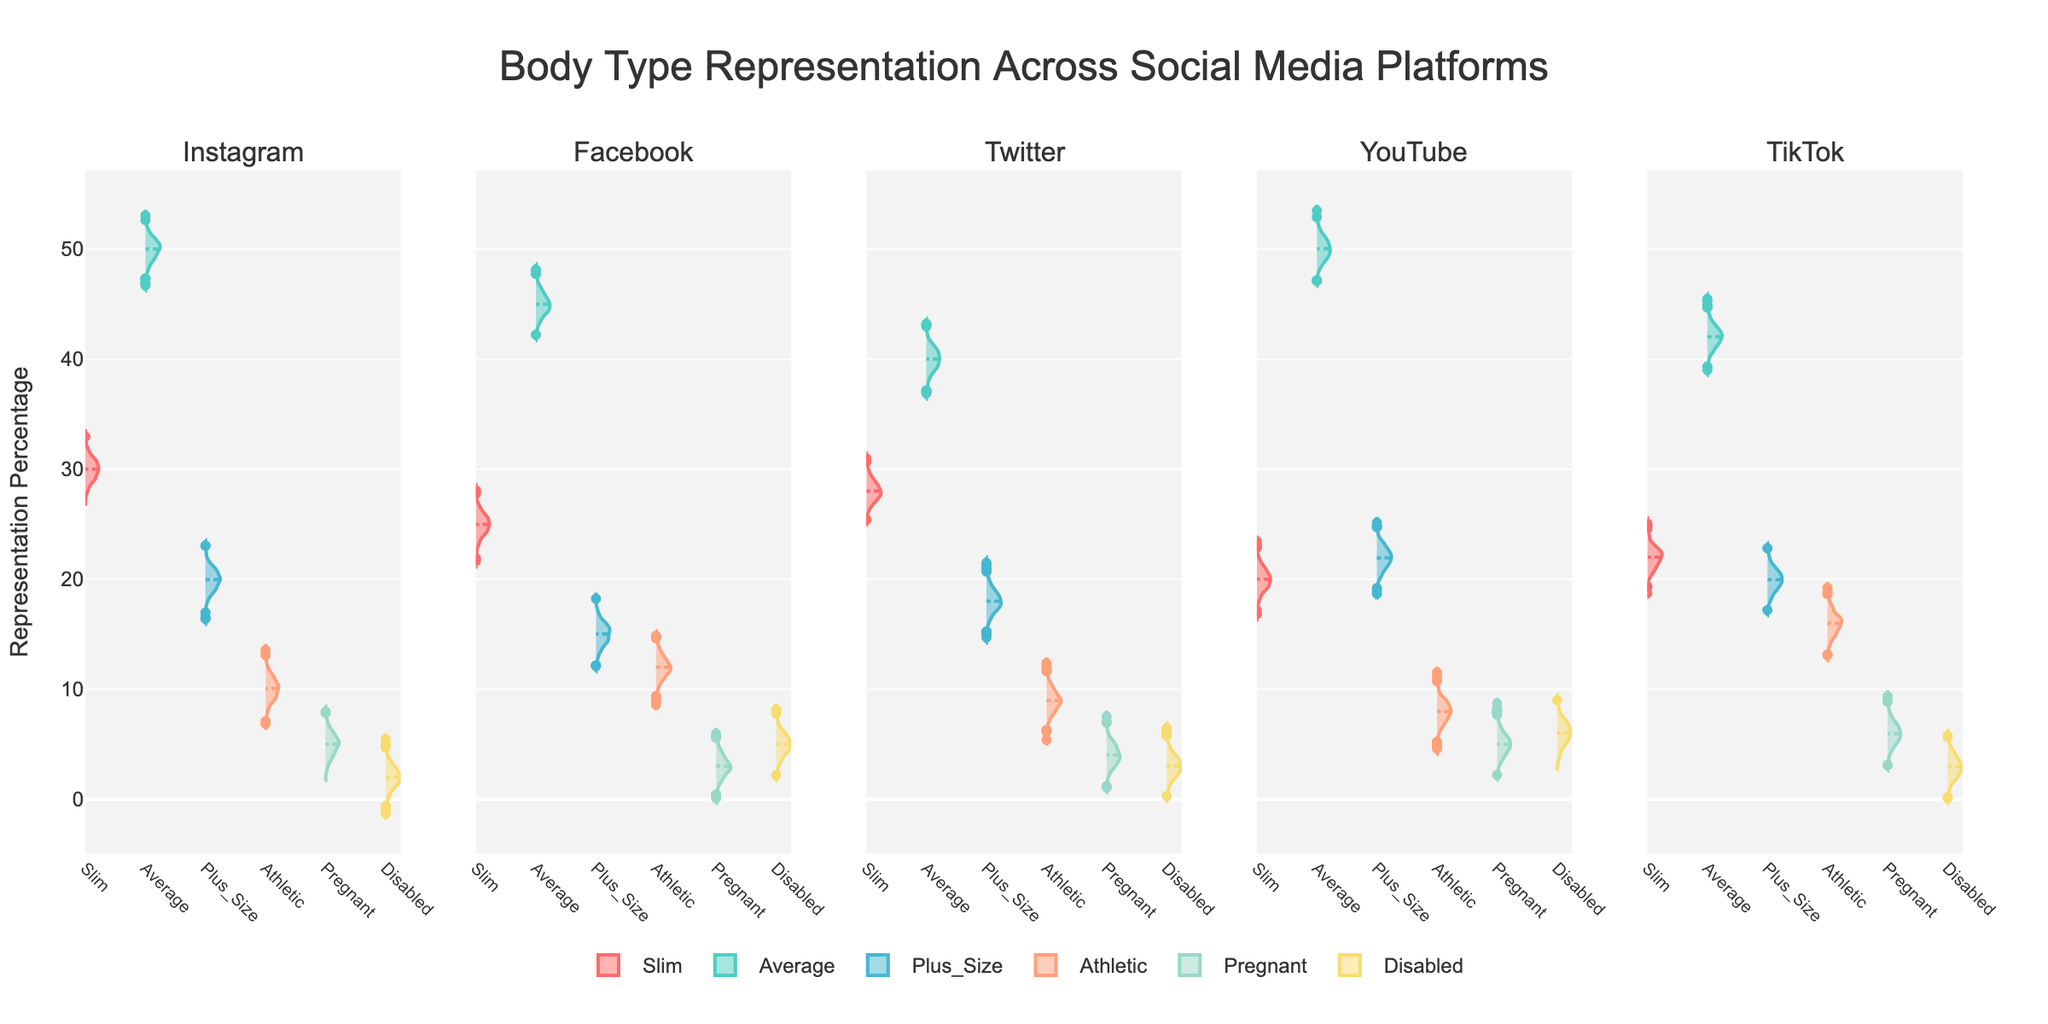What's the title of the figure? The title of the figure appears at the top center of the plot.
Answer: Body Type Representation Across Social Media Platforms How many platforms are being compared in the figure? By observing the subplot titles, we see that there are five platforms.
Answer: 5 Which body type has the highest representation percentage on Instagram? By examining the violin plots for Instagram, the Average body type segment has the most extensive representation.
Answer: Average Between Facebook and YouTube, which platform has a higher representation percentage for Plus Size body types? By comparing the violin plots, YouTube shows a higher representation percentage for Plus Size body types compared to Facebook.
Answer: YouTube What is the largest representation percentage of any body type on Twitter? By looking at the violin plots for Twitter, the largest representation percentage is for Average body type.
Answer: 40 On TikTok, which body type has the lowest representation percentage? The violin plot for TikTok shows that the Disabled body type has the smallest representation percentage.
Answer: Disabled Compare the representation of Athletic body types between Instagram and TikTok. Which platform has a higher percentage? Comparing the violin plots for Athletic body type on both platforms, TikTok has a higher percentage than Instagram.
Answer: TikTok Which platform shows the smallest representation percentage for Pregnant body types? By looking across the violin plots for Pregnant body types, Facebook has the smallest representation percentage.
Answer: Facebook What percentage of body types fall under Slim on YouTube? By examining the violin plot for Slim body type on YouTube, the representation percentage is found.
Answer: 20 Among all body types on all platforms, which body type has the second highest representation percentage on the figure? By examining all the violin plots, the Average body type on YouTube has a representation percentage of 50%, which is second highest.
Answer: Average on YouTube 